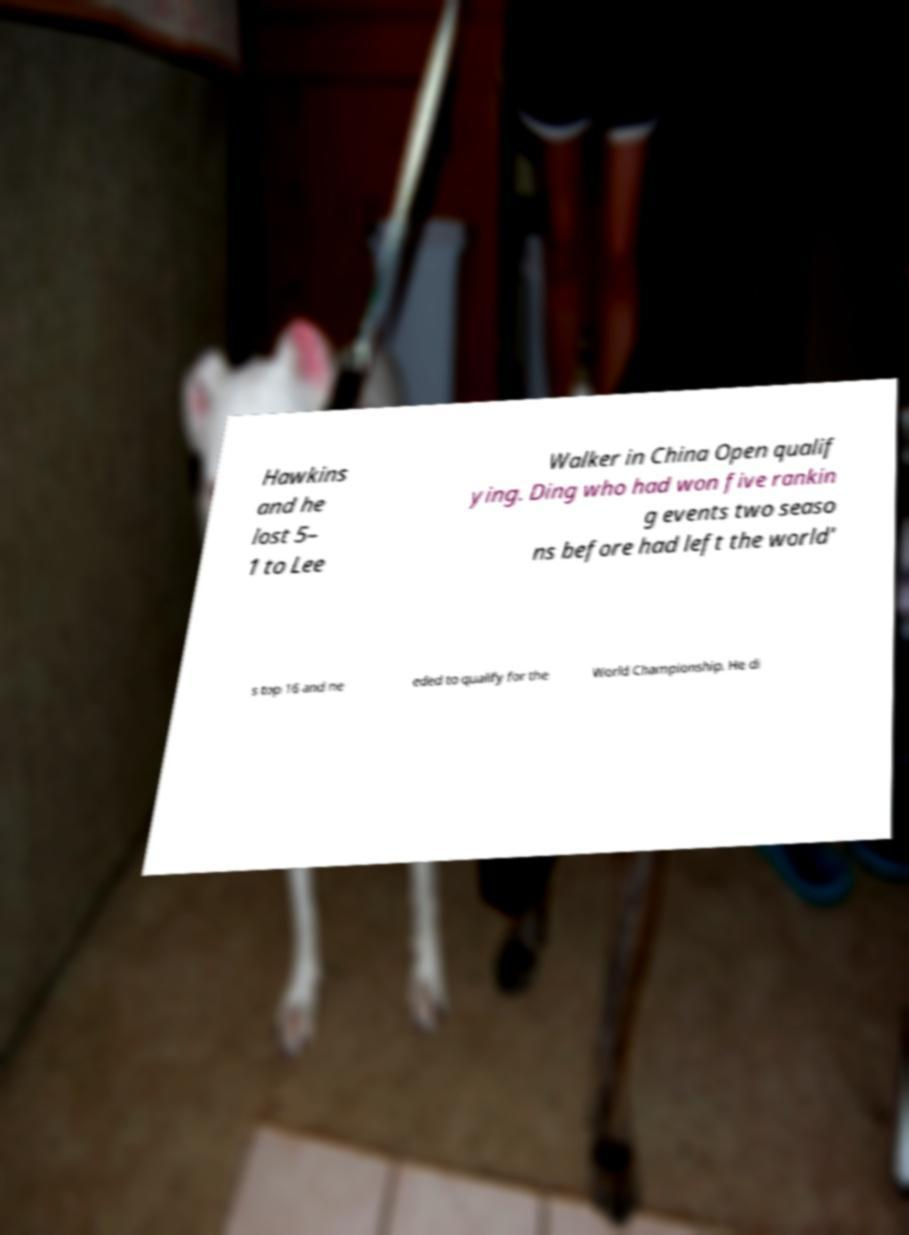Please identify and transcribe the text found in this image. Hawkins and he lost 5– 1 to Lee Walker in China Open qualif ying. Ding who had won five rankin g events two seaso ns before had left the world' s top 16 and ne eded to qualify for the World Championship. He di 